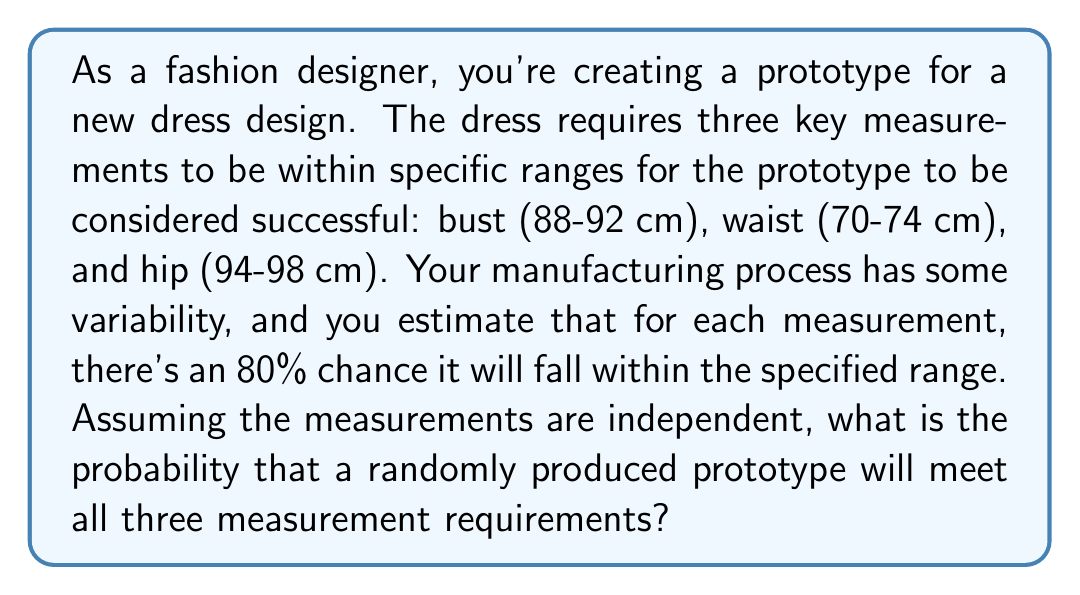Show me your answer to this math problem. Let's approach this step-by-step:

1) First, we need to understand what the question is asking. We're looking for the probability that all three measurements (bust, waist, and hip) fall within their respective ranges.

2) We're told that for each measurement, there's an 80% chance it will fall within the specified range. This can be expressed as a probability of 0.8 for each measurement.

3) The question states that the measurements are independent. This means we can use the multiplication rule of probability for independent events.

4) The multiplication rule states that for independent events A, B, and C, the probability of all events occurring is:

   $$P(A \text{ and } B \text{ and } C) = P(A) \times P(B) \times P(C)$$

5) In this case:
   - Let A be the event that the bust measurement is within range
   - Let B be the event that the waist measurement is within range
   - Let C be the event that the hip measurement is within range

6) We know that $P(A) = P(B) = P(C) = 0.8$

7) Applying the multiplication rule:

   $$P(A \text{ and } B \text{ and } C) = 0.8 \times 0.8 \times 0.8 = 0.8^3 = 0.512$$

8) Therefore, the probability that a randomly produced prototype will meet all three measurement requirements is 0.512 or 51.2%.
Answer: The probability that a randomly produced prototype will meet all three measurement requirements is 0.512 or 51.2%. 